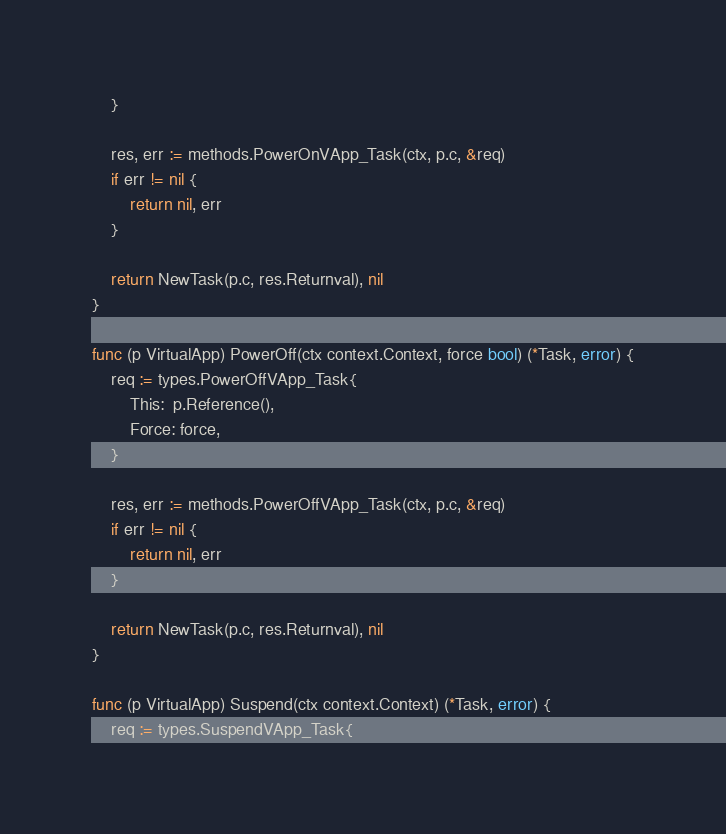Convert code to text. <code><loc_0><loc_0><loc_500><loc_500><_Go_>	}

	res, err := methods.PowerOnVApp_Task(ctx, p.c, &req)
	if err != nil {
		return nil, err
	}

	return NewTask(p.c, res.Returnval), nil
}

func (p VirtualApp) PowerOff(ctx context.Context, force bool) (*Task, error) {
	req := types.PowerOffVApp_Task{
		This:  p.Reference(),
		Force: force,
	}

	res, err := methods.PowerOffVApp_Task(ctx, p.c, &req)
	if err != nil {
		return nil, err
	}

	return NewTask(p.c, res.Returnval), nil
}

func (p VirtualApp) Suspend(ctx context.Context) (*Task, error) {
	req := types.SuspendVApp_Task{</code> 